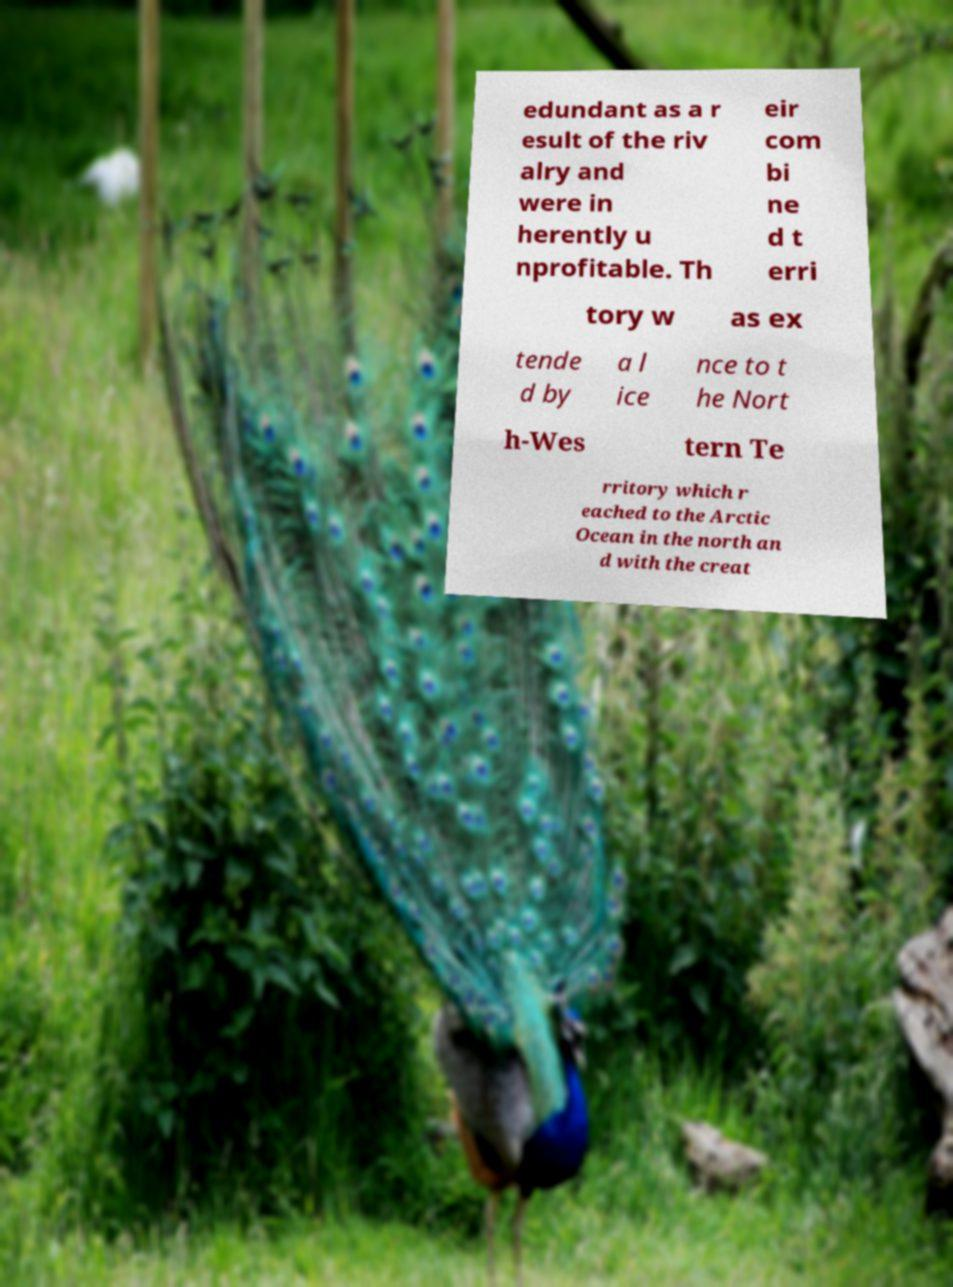There's text embedded in this image that I need extracted. Can you transcribe it verbatim? edundant as a r esult of the riv alry and were in herently u nprofitable. Th eir com bi ne d t erri tory w as ex tende d by a l ice nce to t he Nort h-Wes tern Te rritory which r eached to the Arctic Ocean in the north an d with the creat 